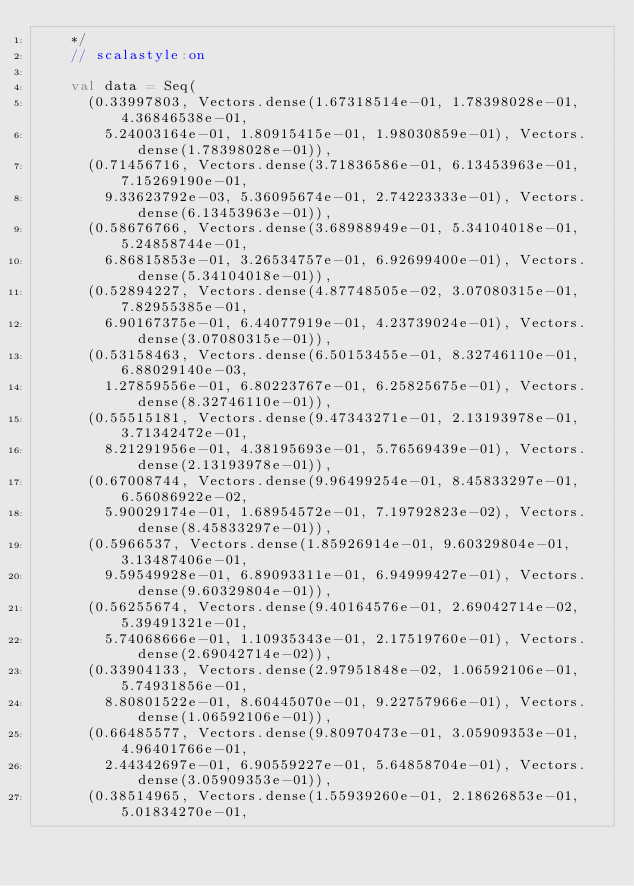Convert code to text. <code><loc_0><loc_0><loc_500><loc_500><_Scala_>    */
    // scalastyle:on

    val data = Seq(
      (0.33997803, Vectors.dense(1.67318514e-01, 1.78398028e-01, 4.36846538e-01,
        5.24003164e-01, 1.80915415e-01, 1.98030859e-01), Vectors.dense(1.78398028e-01)),
      (0.71456716, Vectors.dense(3.71836586e-01, 6.13453963e-01, 7.15269190e-01,
        9.33623792e-03, 5.36095674e-01, 2.74223333e-01), Vectors.dense(6.13453963e-01)),
      (0.58676766, Vectors.dense(3.68988949e-01, 5.34104018e-01, 5.24858744e-01,
        6.86815853e-01, 3.26534757e-01, 6.92699400e-01), Vectors.dense(5.34104018e-01)),
      (0.52894227, Vectors.dense(4.87748505e-02, 3.07080315e-01, 7.82955385e-01,
        6.90167375e-01, 6.44077919e-01, 4.23739024e-01), Vectors.dense(3.07080315e-01)),
      (0.53158463, Vectors.dense(6.50153455e-01, 8.32746110e-01, 6.88029140e-03,
        1.27859556e-01, 6.80223767e-01, 6.25825675e-01), Vectors.dense(8.32746110e-01)),
      (0.55515181, Vectors.dense(9.47343271e-01, 2.13193978e-01, 3.71342472e-01,
        8.21291956e-01, 4.38195693e-01, 5.76569439e-01), Vectors.dense(2.13193978e-01)),
      (0.67008744, Vectors.dense(9.96499254e-01, 8.45833297e-01, 6.56086922e-02,
        5.90029174e-01, 1.68954572e-01, 7.19792823e-02), Vectors.dense(8.45833297e-01)),
      (0.5966537, Vectors.dense(1.85926914e-01, 9.60329804e-01, 3.13487406e-01,
        9.59549928e-01, 6.89093311e-01, 6.94999427e-01), Vectors.dense(9.60329804e-01)),
      (0.56255674, Vectors.dense(9.40164576e-01, 2.69042714e-02, 5.39491321e-01,
        5.74068666e-01, 1.10935343e-01, 2.17519760e-01), Vectors.dense(2.69042714e-02)),
      (0.33904133, Vectors.dense(2.97951848e-02, 1.06592106e-01, 5.74931856e-01,
        8.80801522e-01, 8.60445070e-01, 9.22757966e-01), Vectors.dense(1.06592106e-01)),
      (0.66485577, Vectors.dense(9.80970473e-01, 3.05909353e-01, 4.96401766e-01,
        2.44342697e-01, 6.90559227e-01, 5.64858704e-01), Vectors.dense(3.05909353e-01)),
      (0.38514965, Vectors.dense(1.55939260e-01, 2.18626853e-01, 5.01834270e-01,</code> 